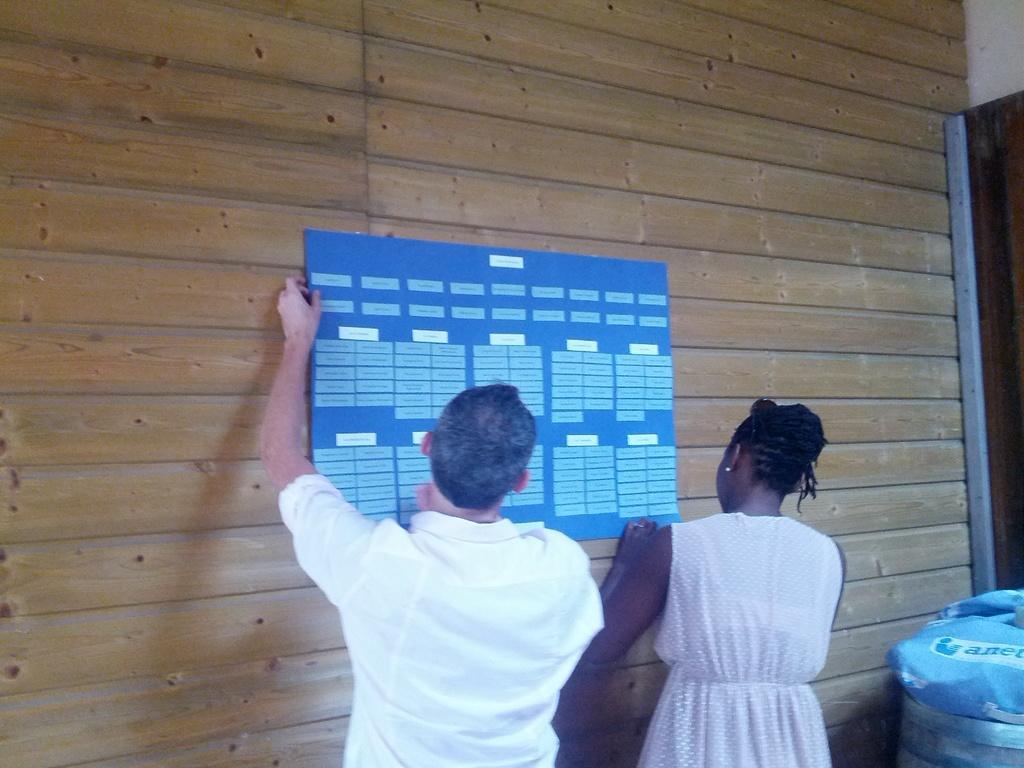Please provide a concise description of this image. In the foreground of this image, there is a man in white dress and a woman in pink dress holding blue colored broad in their hand and pasting it on wooden wall. On the right bottom corner, there is a blue colored object. 